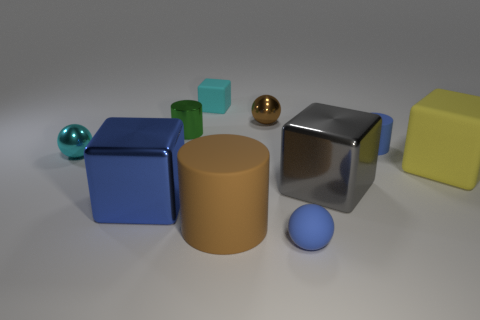Subtract all green metallic cylinders. How many cylinders are left? 2 Subtract 2 cubes. How many cubes are left? 2 Subtract all cylinders. How many objects are left? 7 Subtract all cyan cubes. Subtract all cyan cylinders. How many cubes are left? 3 Subtract all red spheres. How many brown blocks are left? 0 Subtract all large yellow objects. Subtract all small cubes. How many objects are left? 8 Add 4 gray objects. How many gray objects are left? 5 Add 7 gray metallic things. How many gray metallic things exist? 8 Subtract all gray blocks. How many blocks are left? 3 Subtract 0 purple spheres. How many objects are left? 10 